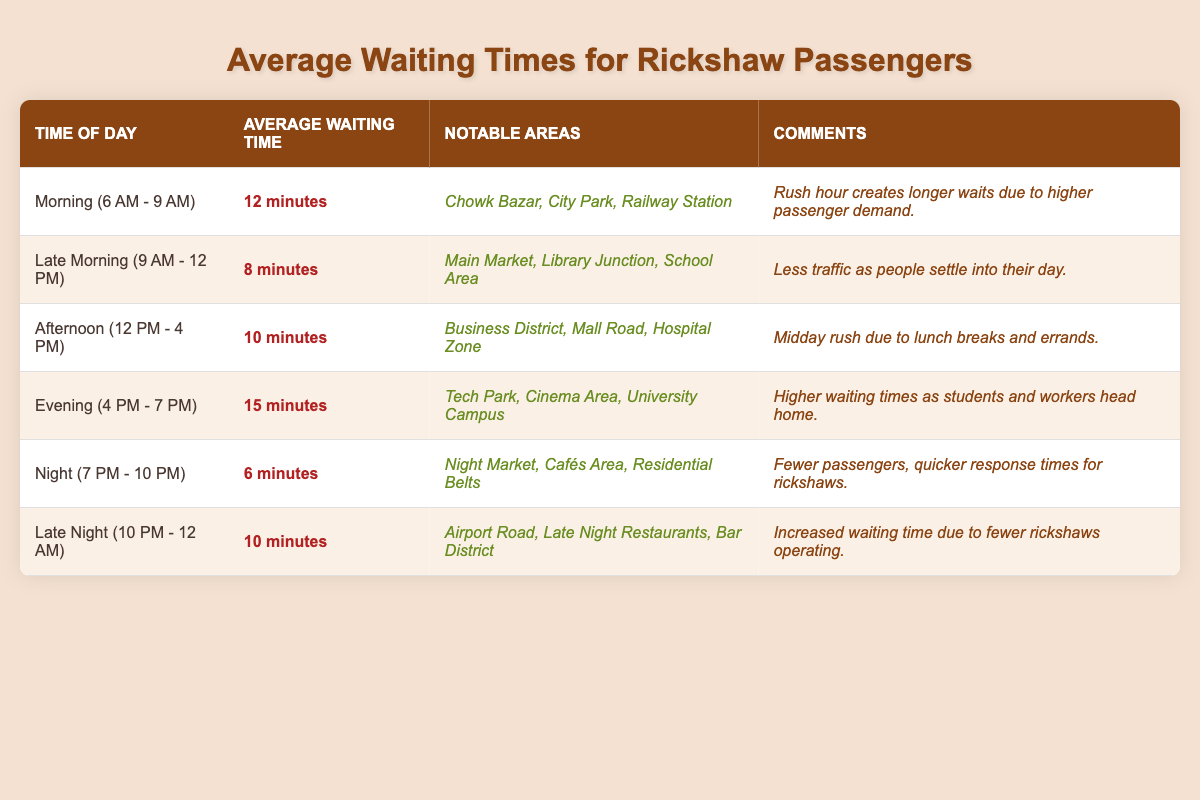What's the average waiting time during the evening? The table states that during the evening (from 4 PM to 7 PM), the average waiting time is 15 minutes.
Answer: 15 minutes Which time of day has the lowest average waiting time? Night (from 7 PM to 10 PM) has the lowest average waiting time of 6 minutes, as per the table.
Answer: 6 minutes How much longer is the waiting time in the evening compared to the night? The evening waiting time is 15 minutes, while the night waiting time is 6 minutes. The difference is 15 - 6 = 9 minutes.
Answer: 9 minutes Are there notable areas listed for the late night time slot? Yes, the table lists Airport Road, Late Night Restaurants, and Bar District as notable areas for the late night time slot.
Answer: Yes What is the total average waiting time during the morning and afternoon? The average waiting time in the morning is 12 minutes, and in the afternoon, it is 10 minutes. The total is 12 + 10 = 22 minutes.
Answer: 22 minutes Does the average waiting time increase or decrease from late morning to evening? The late morning average waiting time is 8 minutes, and the evening average is 15 minutes, indicating an increase of 15 - 8 = 7 minutes.
Answer: Increase Which time slot has the highest average waiting time? The evening time slot has the highest average waiting time of 15 minutes, as shown in the table.
Answer: Evening What is the average waiting time between late morning and late night? The late morning average is 8 minutes, and the late night average is 10 minutes. The average of these two is (8 + 10) / 2 = 9 minutes.
Answer: 9 minutes Are the notable areas for the afternoon and late night the same? No, the notable areas for the afternoon are different from those for the late night; they do not overlap.
Answer: No If a passenger waits 10 minutes during the afternoon, how does that compare to the average? The average waiting time during the afternoon is 10 minutes, so waiting this time is exactly the same as the average.
Answer: Same as average 